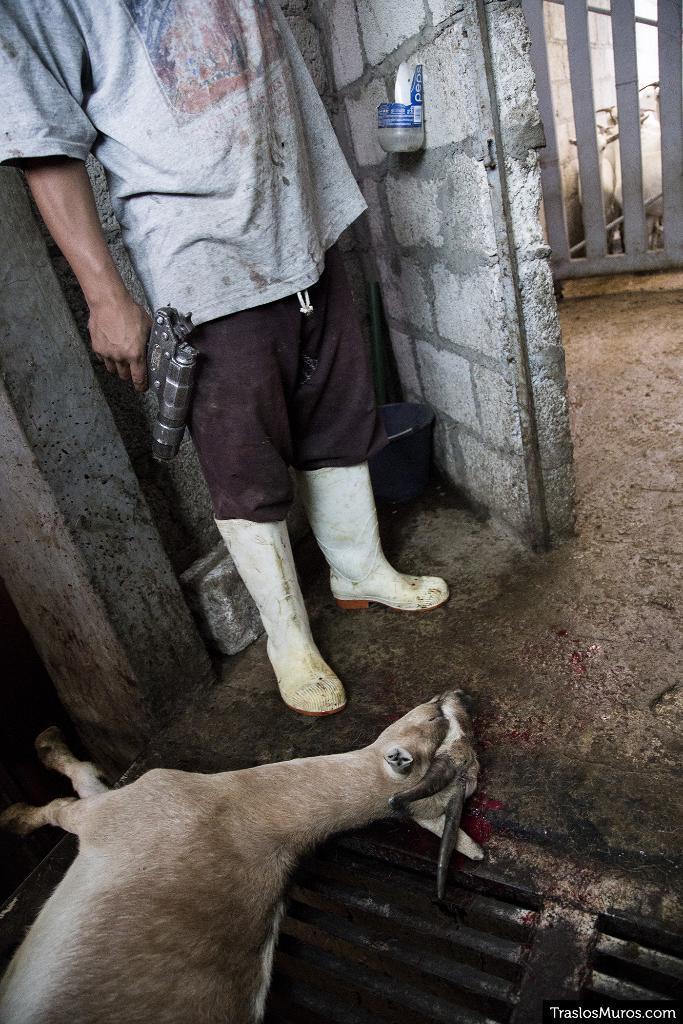Could you give a brief overview of what you see in this image? In the image there is a goat laying on the floor and in the middle there is a man standing with a gun in his hands beside a wall, this seems to be a slaughter home. 